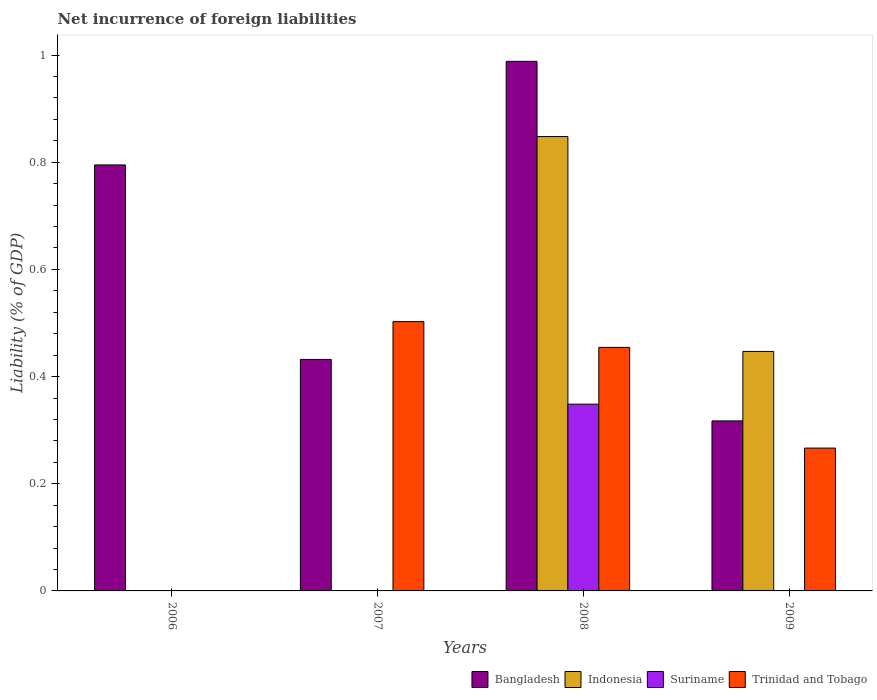How many different coloured bars are there?
Offer a very short reply. 4. Are the number of bars on each tick of the X-axis equal?
Offer a terse response. No. What is the label of the 3rd group of bars from the left?
Offer a terse response. 2008. Across all years, what is the maximum net incurrence of foreign liabilities in Indonesia?
Provide a short and direct response. 0.85. What is the total net incurrence of foreign liabilities in Bangladesh in the graph?
Your response must be concise. 2.53. What is the difference between the net incurrence of foreign liabilities in Bangladesh in 2008 and that in 2009?
Your answer should be very brief. 0.67. What is the difference between the net incurrence of foreign liabilities in Bangladesh in 2008 and the net incurrence of foreign liabilities in Trinidad and Tobago in 2009?
Provide a short and direct response. 0.72. What is the average net incurrence of foreign liabilities in Indonesia per year?
Your answer should be very brief. 0.32. In the year 2007, what is the difference between the net incurrence of foreign liabilities in Bangladesh and net incurrence of foreign liabilities in Trinidad and Tobago?
Make the answer very short. -0.07. What is the ratio of the net incurrence of foreign liabilities in Bangladesh in 2006 to that in 2007?
Keep it short and to the point. 1.84. Is the net incurrence of foreign liabilities in Bangladesh in 2006 less than that in 2007?
Offer a very short reply. No. Is the difference between the net incurrence of foreign liabilities in Bangladesh in 2007 and 2009 greater than the difference between the net incurrence of foreign liabilities in Trinidad and Tobago in 2007 and 2009?
Keep it short and to the point. No. What is the difference between the highest and the second highest net incurrence of foreign liabilities in Trinidad and Tobago?
Provide a succinct answer. 0.05. What is the difference between the highest and the lowest net incurrence of foreign liabilities in Suriname?
Provide a short and direct response. 0.35. Is it the case that in every year, the sum of the net incurrence of foreign liabilities in Bangladesh and net incurrence of foreign liabilities in Suriname is greater than the net incurrence of foreign liabilities in Trinidad and Tobago?
Your answer should be compact. No. Are all the bars in the graph horizontal?
Ensure brevity in your answer.  No. What is the difference between two consecutive major ticks on the Y-axis?
Provide a succinct answer. 0.2. How are the legend labels stacked?
Give a very brief answer. Horizontal. What is the title of the graph?
Provide a short and direct response. Net incurrence of foreign liabilities. Does "Argentina" appear as one of the legend labels in the graph?
Your answer should be compact. No. What is the label or title of the Y-axis?
Your response must be concise. Liability (% of GDP). What is the Liability (% of GDP) in Bangladesh in 2006?
Offer a very short reply. 0.8. What is the Liability (% of GDP) in Indonesia in 2006?
Your response must be concise. 0. What is the Liability (% of GDP) in Bangladesh in 2007?
Your answer should be very brief. 0.43. What is the Liability (% of GDP) in Indonesia in 2007?
Ensure brevity in your answer.  0. What is the Liability (% of GDP) of Suriname in 2007?
Provide a short and direct response. 0. What is the Liability (% of GDP) of Trinidad and Tobago in 2007?
Ensure brevity in your answer.  0.5. What is the Liability (% of GDP) in Bangladesh in 2008?
Give a very brief answer. 0.99. What is the Liability (% of GDP) in Indonesia in 2008?
Your answer should be compact. 0.85. What is the Liability (% of GDP) of Suriname in 2008?
Give a very brief answer. 0.35. What is the Liability (% of GDP) in Trinidad and Tobago in 2008?
Offer a very short reply. 0.45. What is the Liability (% of GDP) in Bangladesh in 2009?
Keep it short and to the point. 0.32. What is the Liability (% of GDP) of Indonesia in 2009?
Offer a terse response. 0.45. What is the Liability (% of GDP) of Trinidad and Tobago in 2009?
Ensure brevity in your answer.  0.27. Across all years, what is the maximum Liability (% of GDP) in Bangladesh?
Offer a terse response. 0.99. Across all years, what is the maximum Liability (% of GDP) of Indonesia?
Ensure brevity in your answer.  0.85. Across all years, what is the maximum Liability (% of GDP) of Suriname?
Your answer should be compact. 0.35. Across all years, what is the maximum Liability (% of GDP) of Trinidad and Tobago?
Your answer should be very brief. 0.5. Across all years, what is the minimum Liability (% of GDP) in Bangladesh?
Keep it short and to the point. 0.32. Across all years, what is the minimum Liability (% of GDP) of Indonesia?
Provide a succinct answer. 0. Across all years, what is the minimum Liability (% of GDP) of Suriname?
Offer a terse response. 0. Across all years, what is the minimum Liability (% of GDP) of Trinidad and Tobago?
Keep it short and to the point. 0. What is the total Liability (% of GDP) in Bangladesh in the graph?
Give a very brief answer. 2.53. What is the total Liability (% of GDP) in Indonesia in the graph?
Your answer should be compact. 1.29. What is the total Liability (% of GDP) of Suriname in the graph?
Keep it short and to the point. 0.35. What is the total Liability (% of GDP) in Trinidad and Tobago in the graph?
Keep it short and to the point. 1.22. What is the difference between the Liability (% of GDP) in Bangladesh in 2006 and that in 2007?
Offer a very short reply. 0.36. What is the difference between the Liability (% of GDP) in Bangladesh in 2006 and that in 2008?
Offer a terse response. -0.19. What is the difference between the Liability (% of GDP) in Bangladesh in 2006 and that in 2009?
Give a very brief answer. 0.48. What is the difference between the Liability (% of GDP) in Bangladesh in 2007 and that in 2008?
Provide a succinct answer. -0.56. What is the difference between the Liability (% of GDP) of Trinidad and Tobago in 2007 and that in 2008?
Offer a very short reply. 0.05. What is the difference between the Liability (% of GDP) of Bangladesh in 2007 and that in 2009?
Ensure brevity in your answer.  0.11. What is the difference between the Liability (% of GDP) of Trinidad and Tobago in 2007 and that in 2009?
Your answer should be compact. 0.24. What is the difference between the Liability (% of GDP) of Bangladesh in 2008 and that in 2009?
Offer a very short reply. 0.67. What is the difference between the Liability (% of GDP) of Indonesia in 2008 and that in 2009?
Provide a succinct answer. 0.4. What is the difference between the Liability (% of GDP) in Trinidad and Tobago in 2008 and that in 2009?
Your answer should be very brief. 0.19. What is the difference between the Liability (% of GDP) of Bangladesh in 2006 and the Liability (% of GDP) of Trinidad and Tobago in 2007?
Provide a succinct answer. 0.29. What is the difference between the Liability (% of GDP) in Bangladesh in 2006 and the Liability (% of GDP) in Indonesia in 2008?
Keep it short and to the point. -0.05. What is the difference between the Liability (% of GDP) of Bangladesh in 2006 and the Liability (% of GDP) of Suriname in 2008?
Offer a very short reply. 0.45. What is the difference between the Liability (% of GDP) of Bangladesh in 2006 and the Liability (% of GDP) of Trinidad and Tobago in 2008?
Offer a terse response. 0.34. What is the difference between the Liability (% of GDP) in Bangladesh in 2006 and the Liability (% of GDP) in Indonesia in 2009?
Offer a very short reply. 0.35. What is the difference between the Liability (% of GDP) of Bangladesh in 2006 and the Liability (% of GDP) of Trinidad and Tobago in 2009?
Ensure brevity in your answer.  0.53. What is the difference between the Liability (% of GDP) of Bangladesh in 2007 and the Liability (% of GDP) of Indonesia in 2008?
Offer a very short reply. -0.42. What is the difference between the Liability (% of GDP) of Bangladesh in 2007 and the Liability (% of GDP) of Suriname in 2008?
Your answer should be compact. 0.08. What is the difference between the Liability (% of GDP) in Bangladesh in 2007 and the Liability (% of GDP) in Trinidad and Tobago in 2008?
Make the answer very short. -0.02. What is the difference between the Liability (% of GDP) of Bangladesh in 2007 and the Liability (% of GDP) of Indonesia in 2009?
Your response must be concise. -0.01. What is the difference between the Liability (% of GDP) of Bangladesh in 2007 and the Liability (% of GDP) of Trinidad and Tobago in 2009?
Offer a very short reply. 0.17. What is the difference between the Liability (% of GDP) in Bangladesh in 2008 and the Liability (% of GDP) in Indonesia in 2009?
Offer a terse response. 0.54. What is the difference between the Liability (% of GDP) in Bangladesh in 2008 and the Liability (% of GDP) in Trinidad and Tobago in 2009?
Give a very brief answer. 0.72. What is the difference between the Liability (% of GDP) in Indonesia in 2008 and the Liability (% of GDP) in Trinidad and Tobago in 2009?
Your answer should be very brief. 0.58. What is the difference between the Liability (% of GDP) of Suriname in 2008 and the Liability (% of GDP) of Trinidad and Tobago in 2009?
Make the answer very short. 0.08. What is the average Liability (% of GDP) in Bangladesh per year?
Ensure brevity in your answer.  0.63. What is the average Liability (% of GDP) of Indonesia per year?
Provide a succinct answer. 0.32. What is the average Liability (% of GDP) in Suriname per year?
Your answer should be very brief. 0.09. What is the average Liability (% of GDP) of Trinidad and Tobago per year?
Provide a succinct answer. 0.31. In the year 2007, what is the difference between the Liability (% of GDP) of Bangladesh and Liability (% of GDP) of Trinidad and Tobago?
Provide a succinct answer. -0.07. In the year 2008, what is the difference between the Liability (% of GDP) in Bangladesh and Liability (% of GDP) in Indonesia?
Offer a terse response. 0.14. In the year 2008, what is the difference between the Liability (% of GDP) in Bangladesh and Liability (% of GDP) in Suriname?
Give a very brief answer. 0.64. In the year 2008, what is the difference between the Liability (% of GDP) in Bangladesh and Liability (% of GDP) in Trinidad and Tobago?
Your answer should be compact. 0.53. In the year 2008, what is the difference between the Liability (% of GDP) in Indonesia and Liability (% of GDP) in Suriname?
Your response must be concise. 0.5. In the year 2008, what is the difference between the Liability (% of GDP) in Indonesia and Liability (% of GDP) in Trinidad and Tobago?
Offer a terse response. 0.39. In the year 2008, what is the difference between the Liability (% of GDP) of Suriname and Liability (% of GDP) of Trinidad and Tobago?
Keep it short and to the point. -0.11. In the year 2009, what is the difference between the Liability (% of GDP) in Bangladesh and Liability (% of GDP) in Indonesia?
Your response must be concise. -0.13. In the year 2009, what is the difference between the Liability (% of GDP) of Bangladesh and Liability (% of GDP) of Trinidad and Tobago?
Keep it short and to the point. 0.05. In the year 2009, what is the difference between the Liability (% of GDP) in Indonesia and Liability (% of GDP) in Trinidad and Tobago?
Offer a terse response. 0.18. What is the ratio of the Liability (% of GDP) of Bangladesh in 2006 to that in 2007?
Provide a short and direct response. 1.84. What is the ratio of the Liability (% of GDP) in Bangladesh in 2006 to that in 2008?
Make the answer very short. 0.8. What is the ratio of the Liability (% of GDP) in Bangladesh in 2006 to that in 2009?
Keep it short and to the point. 2.51. What is the ratio of the Liability (% of GDP) of Bangladesh in 2007 to that in 2008?
Make the answer very short. 0.44. What is the ratio of the Liability (% of GDP) of Trinidad and Tobago in 2007 to that in 2008?
Your answer should be very brief. 1.11. What is the ratio of the Liability (% of GDP) of Bangladesh in 2007 to that in 2009?
Give a very brief answer. 1.36. What is the ratio of the Liability (% of GDP) in Trinidad and Tobago in 2007 to that in 2009?
Your answer should be compact. 1.89. What is the ratio of the Liability (% of GDP) of Bangladesh in 2008 to that in 2009?
Your answer should be very brief. 3.11. What is the ratio of the Liability (% of GDP) of Indonesia in 2008 to that in 2009?
Keep it short and to the point. 1.9. What is the ratio of the Liability (% of GDP) in Trinidad and Tobago in 2008 to that in 2009?
Ensure brevity in your answer.  1.71. What is the difference between the highest and the second highest Liability (% of GDP) of Bangladesh?
Offer a terse response. 0.19. What is the difference between the highest and the second highest Liability (% of GDP) in Trinidad and Tobago?
Your answer should be compact. 0.05. What is the difference between the highest and the lowest Liability (% of GDP) of Bangladesh?
Make the answer very short. 0.67. What is the difference between the highest and the lowest Liability (% of GDP) in Indonesia?
Provide a succinct answer. 0.85. What is the difference between the highest and the lowest Liability (% of GDP) of Suriname?
Give a very brief answer. 0.35. What is the difference between the highest and the lowest Liability (% of GDP) of Trinidad and Tobago?
Provide a succinct answer. 0.5. 